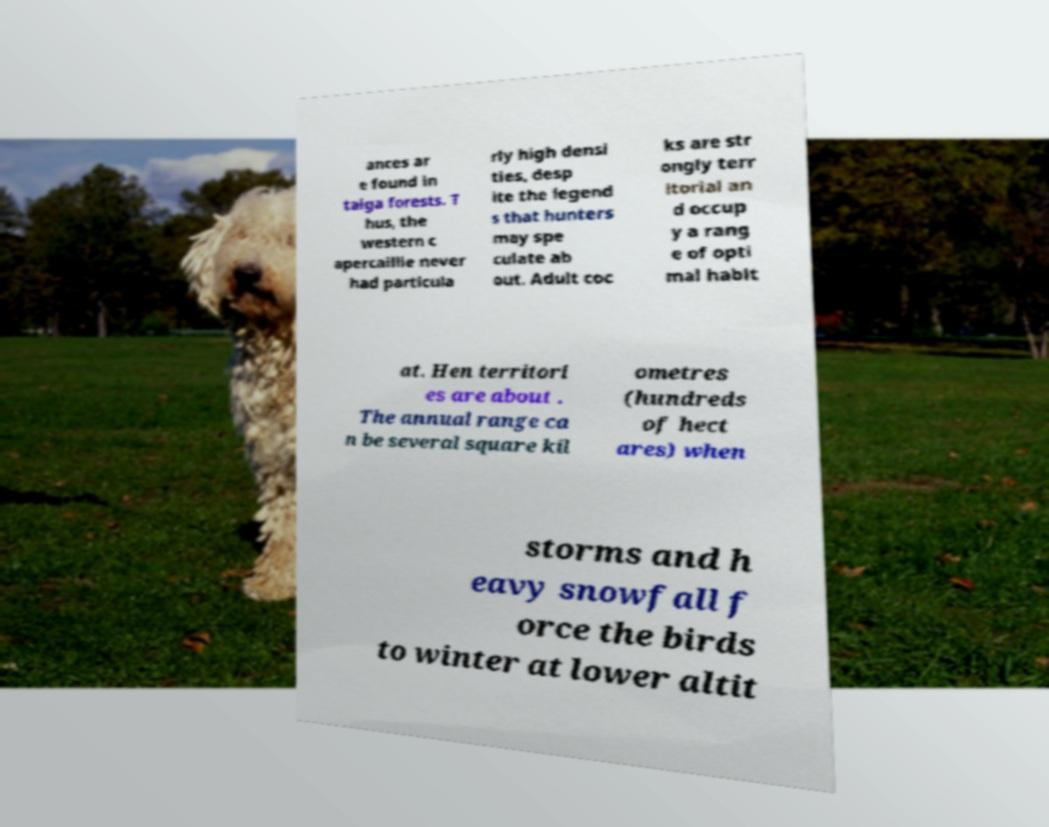Please identify and transcribe the text found in this image. ances ar e found in taiga forests. T hus, the western c apercaillie never had particula rly high densi ties, desp ite the legend s that hunters may spe culate ab out. Adult coc ks are str ongly terr itorial an d occup y a rang e of opti mal habit at. Hen territori es are about . The annual range ca n be several square kil ometres (hundreds of hect ares) when storms and h eavy snowfall f orce the birds to winter at lower altit 